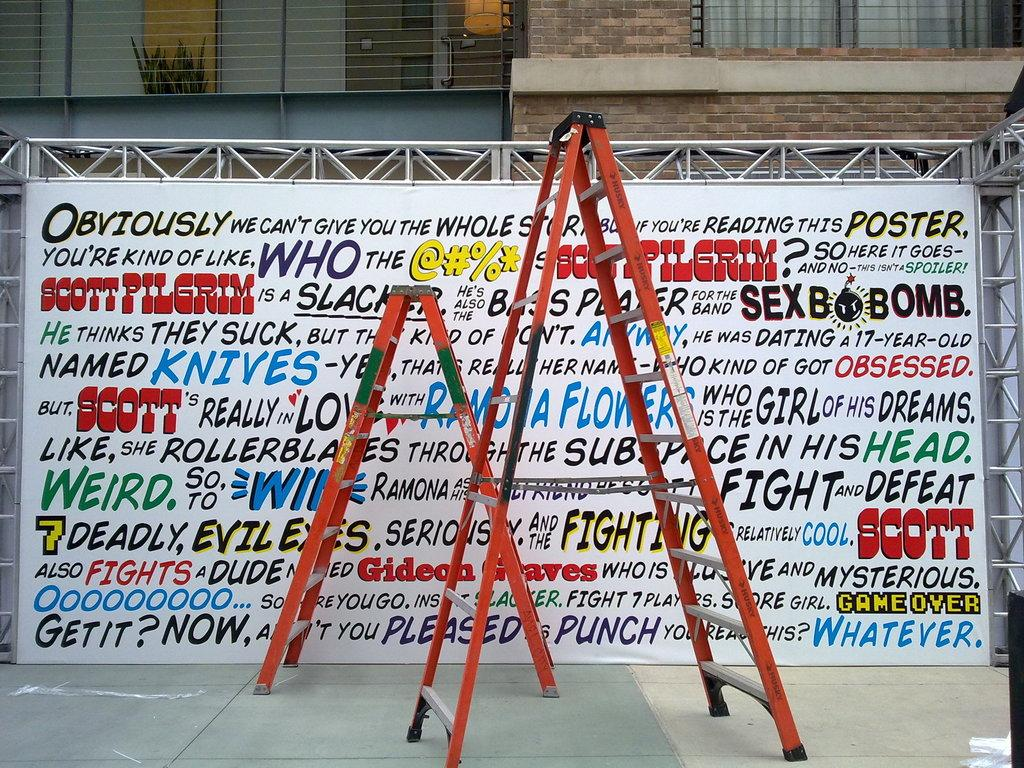<image>
Summarize the visual content of the image. A lot of writing on a poster but the it starts with the word Obviously in black. 